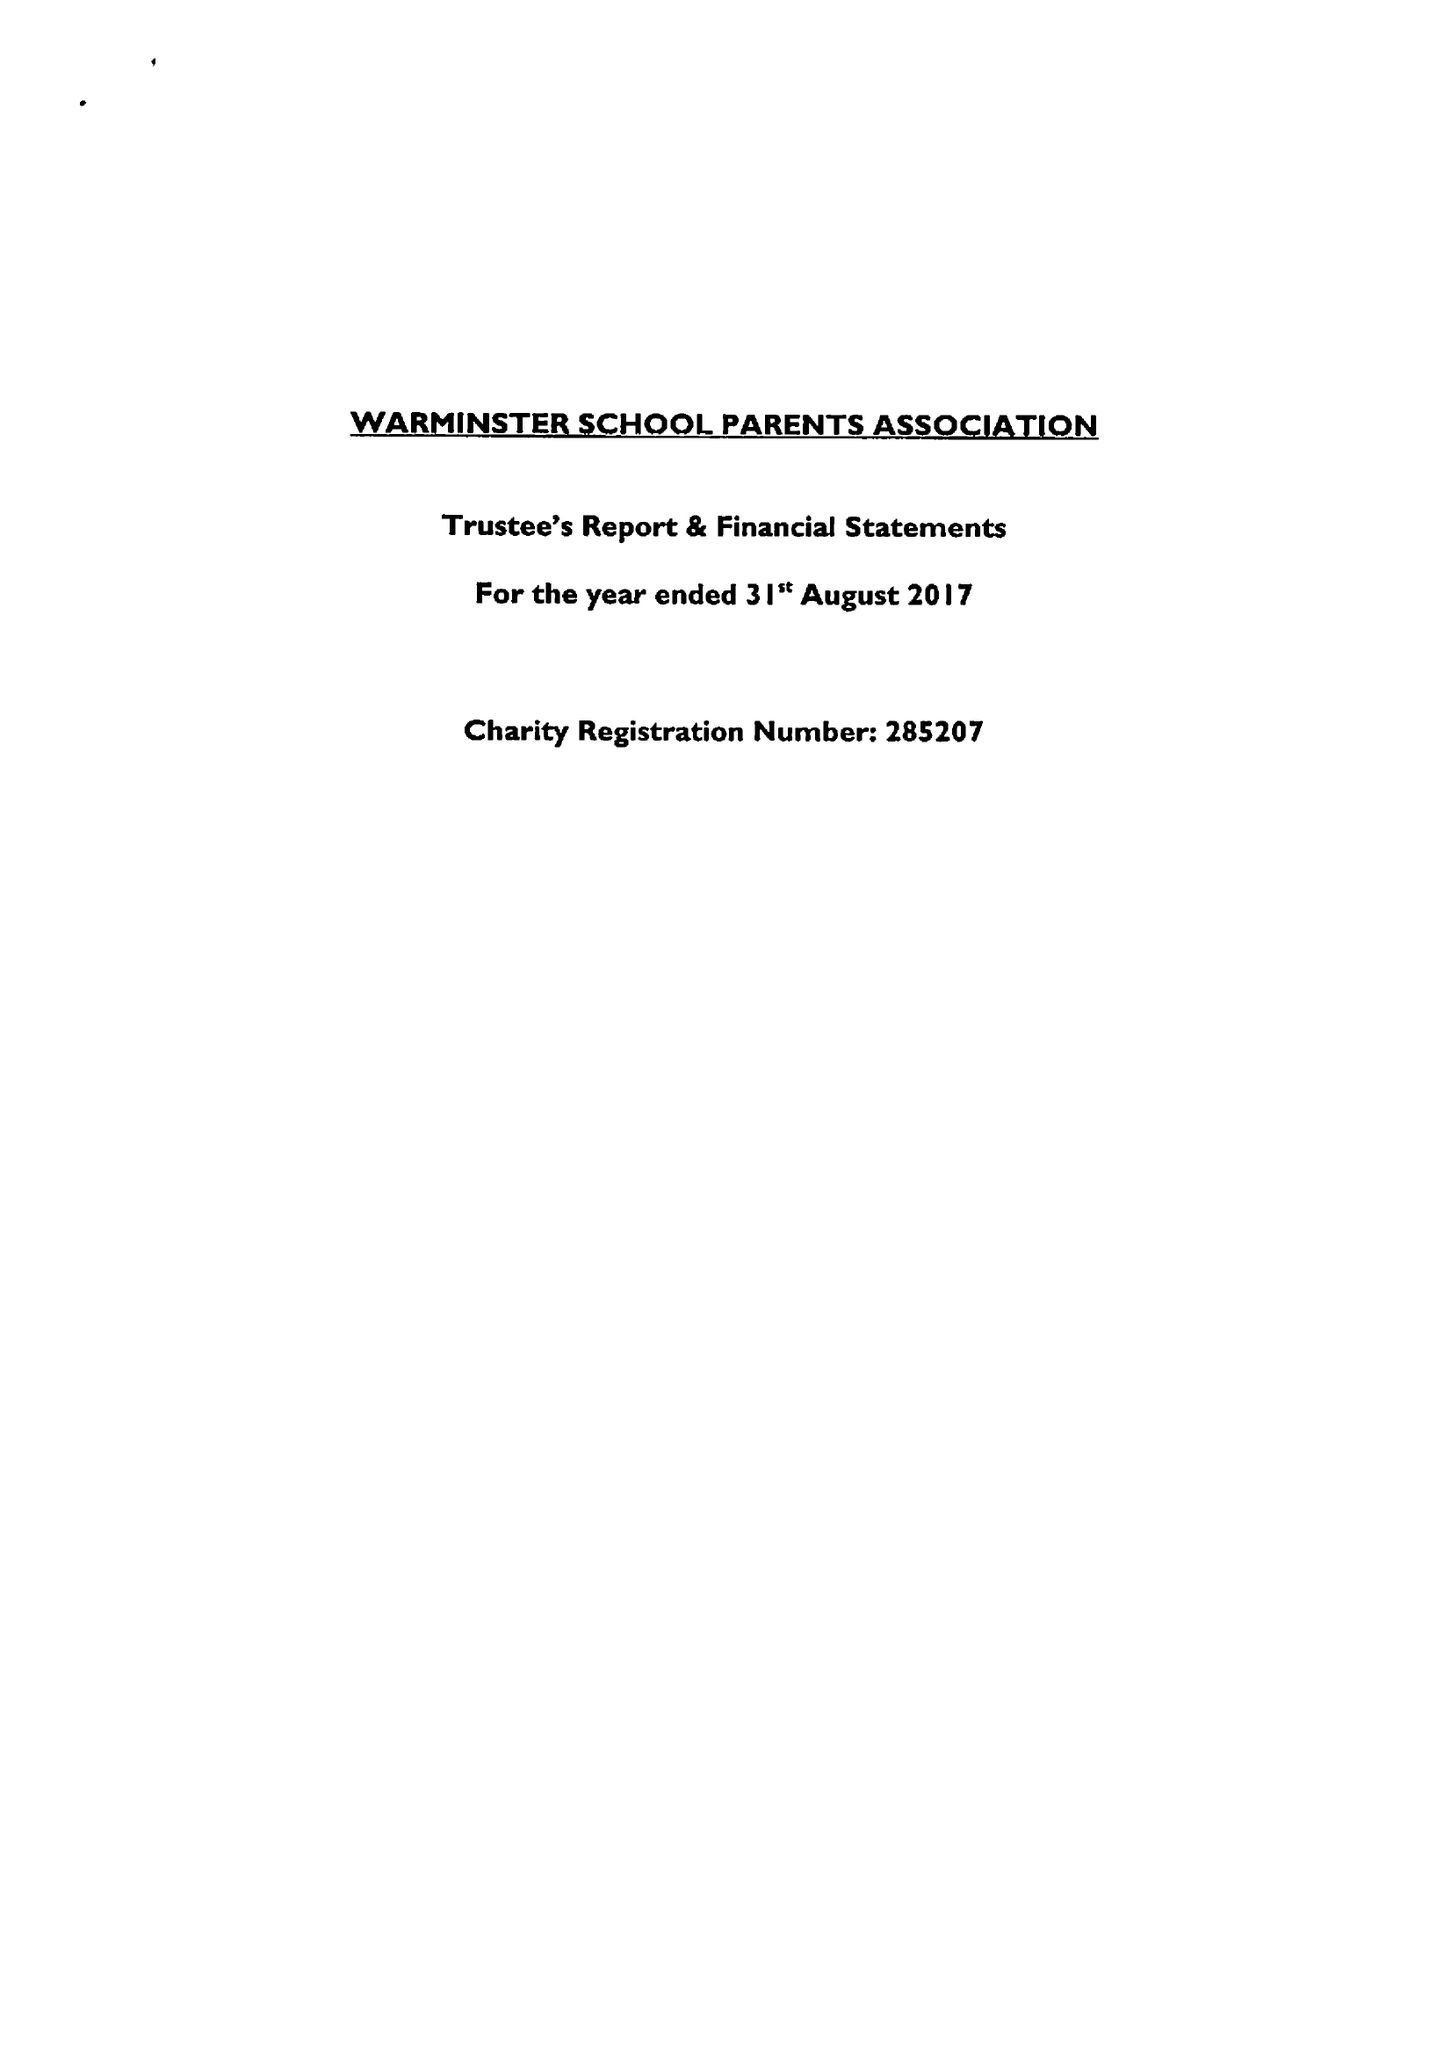What is the value for the address__street_line?
Answer the question using a single word or phrase. CHURCH STREET 